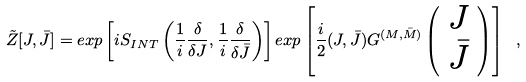<formula> <loc_0><loc_0><loc_500><loc_500>\tilde { Z } [ J , \bar { J } ] = e x p \left [ i S _ { I N T } \left ( \frac { 1 } { i } \frac { \delta } { \delta J } , \frac { 1 } { i } \frac { \delta } { \delta \bar { J } } \right ) \right ] e x p \left [ \frac { i } { 2 } ( J , \bar { J } ) G ^ { ( M , \bar { M } ) } \left ( \begin{array} { c } J \\ \bar { J } \end{array} \right ) \right ] \ ,</formula> 